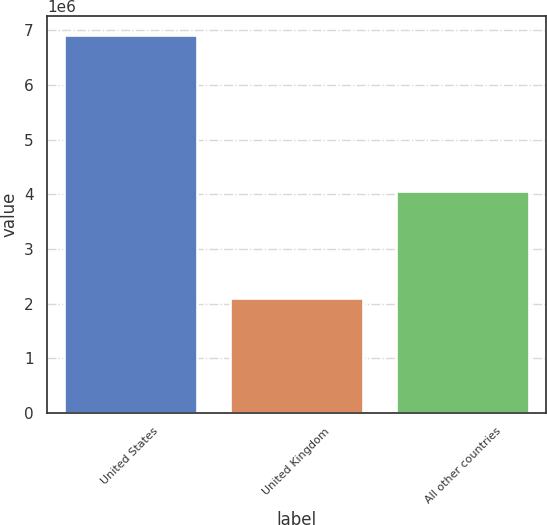Convert chart. <chart><loc_0><loc_0><loc_500><loc_500><bar_chart><fcel>United States<fcel>United Kingdom<fcel>All other countries<nl><fcel>6.91722e+06<fcel>2.09495e+06<fcel>4.05942e+06<nl></chart> 